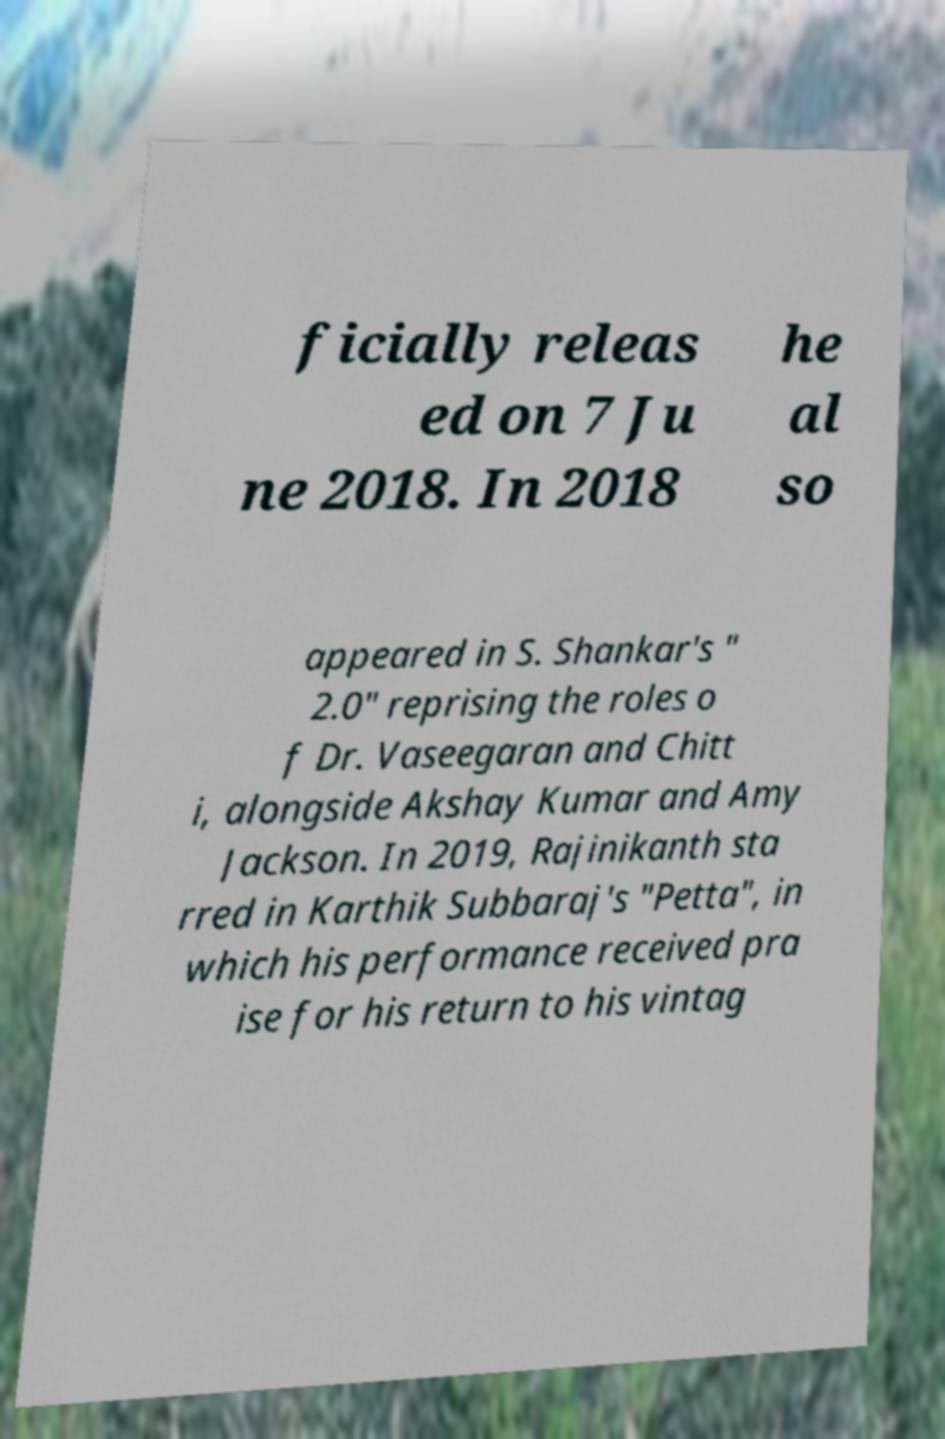I need the written content from this picture converted into text. Can you do that? ficially releas ed on 7 Ju ne 2018. In 2018 he al so appeared in S. Shankar's " 2.0" reprising the roles o f Dr. Vaseegaran and Chitt i, alongside Akshay Kumar and Amy Jackson. In 2019, Rajinikanth sta rred in Karthik Subbaraj's "Petta", in which his performance received pra ise for his return to his vintag 